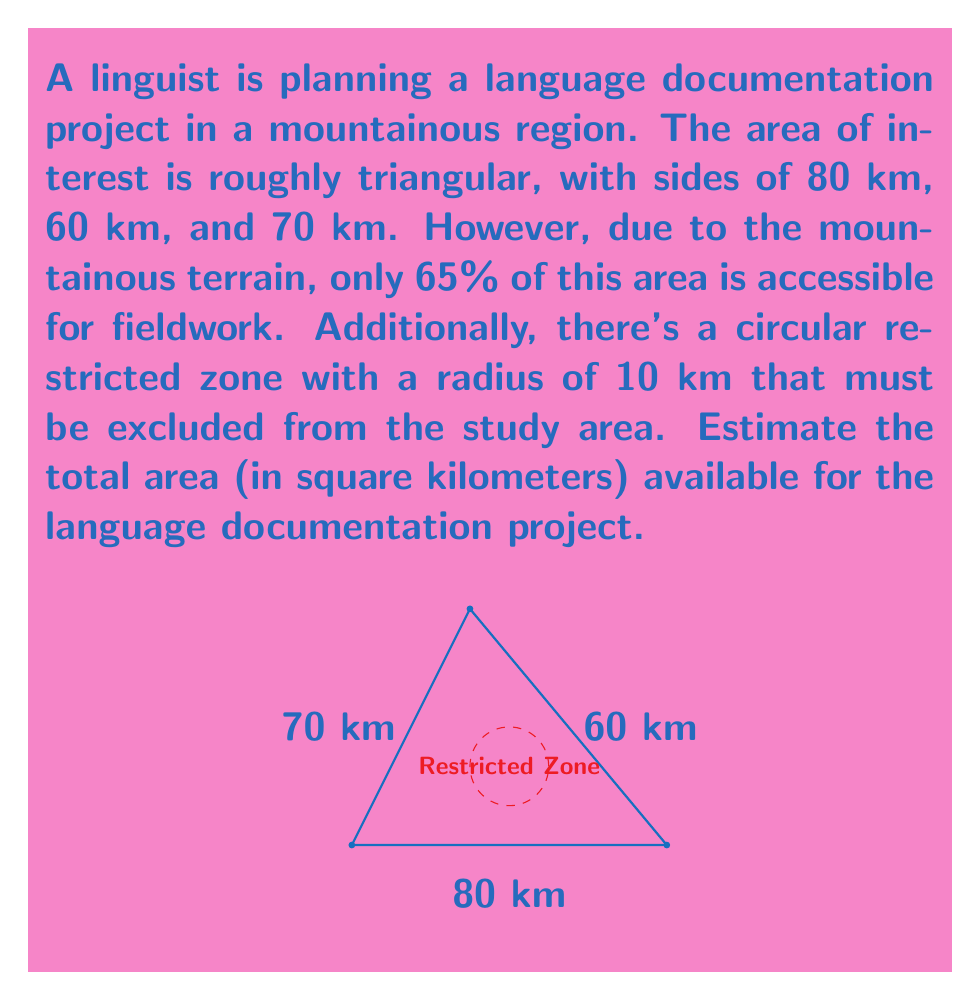Provide a solution to this math problem. Let's approach this problem step-by-step:

1) First, calculate the total area of the triangular region using Heron's formula:
   $$s = \frac{a + b + c}{2} = \frac{80 + 60 + 70}{2} = 105$$
   $$A = \sqrt{s(s-a)(s-b)(s-c)}$$
   $$A = \sqrt{105(105-80)(105-60)(105-70)}$$
   $$A = \sqrt{105 \cdot 25 \cdot 45 \cdot 35} = 2076.69 \text{ km}^2$$

2) Only 65% of this area is accessible:
   $$\text{Accessible area} = 2076.69 \cdot 0.65 = 1349.85 \text{ km}^2$$

3) Calculate the area of the restricted zone:
   $$\text{Restricted area} = \pi r^2 = \pi \cdot 10^2 = 314.16 \text{ km}^2$$

4) Subtract the restricted area from the accessible area:
   $$\text{Available area} = 1349.85 - 314.16 = 1035.69 \text{ km}^2$$

5) Round to the nearest whole number:
   $$\text{Final estimate} = 1036 \text{ km}^2$$
Answer: 1036 km² 